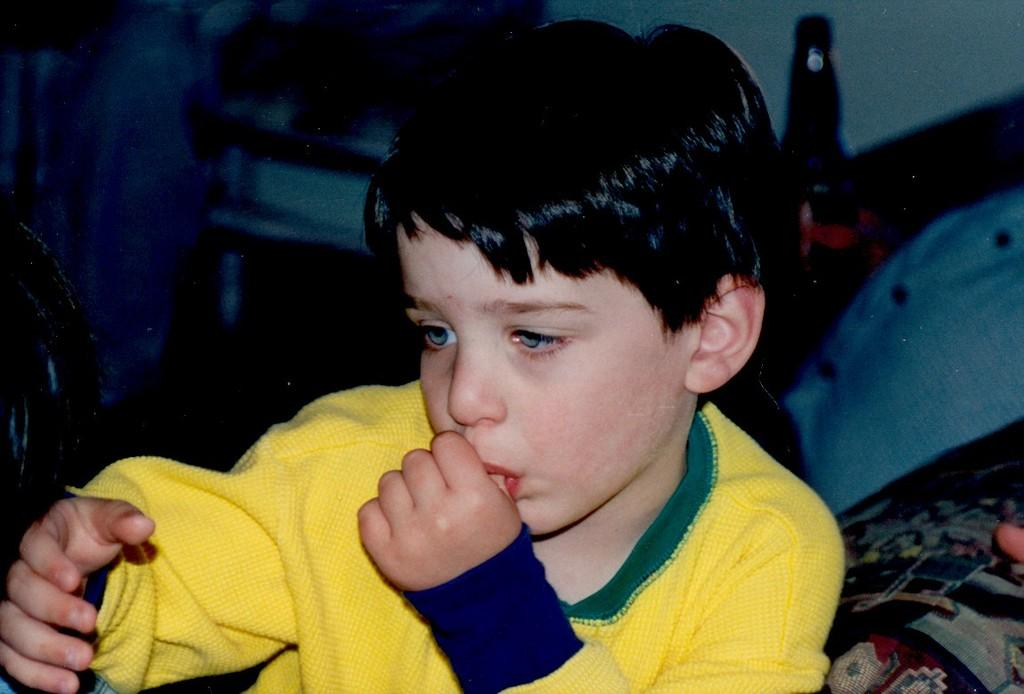What is the main subject in the front of the image? There is a kid in the front of the image. What can be seen in the background of the image? There is a bed and other objects in the background of the image. What type of structure is visible in the background? There is a wall in the background of the image. What type of humor can be seen in the image? There is no humor present in the image; it is a simple scene featuring a kid and a background with a bed, objects, and a wall. 